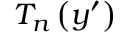<formula> <loc_0><loc_0><loc_500><loc_500>T _ { n } \left ( y ^ { \prime } \right )</formula> 